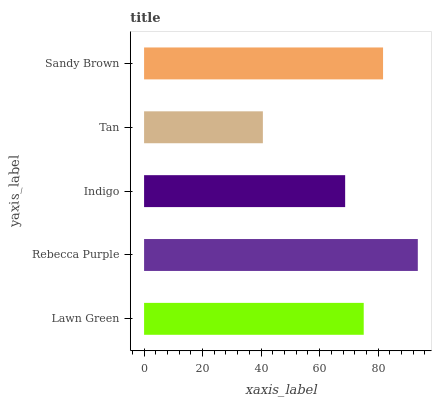Is Tan the minimum?
Answer yes or no. Yes. Is Rebecca Purple the maximum?
Answer yes or no. Yes. Is Indigo the minimum?
Answer yes or no. No. Is Indigo the maximum?
Answer yes or no. No. Is Rebecca Purple greater than Indigo?
Answer yes or no. Yes. Is Indigo less than Rebecca Purple?
Answer yes or no. Yes. Is Indigo greater than Rebecca Purple?
Answer yes or no. No. Is Rebecca Purple less than Indigo?
Answer yes or no. No. Is Lawn Green the high median?
Answer yes or no. Yes. Is Lawn Green the low median?
Answer yes or no. Yes. Is Tan the high median?
Answer yes or no. No. Is Sandy Brown the low median?
Answer yes or no. No. 